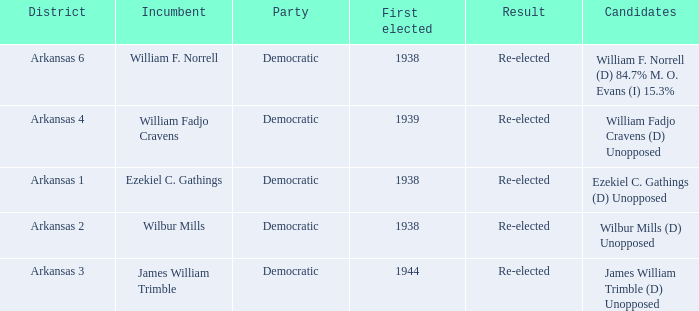How many incumbents had a district of Arkansas 3? 1.0. 